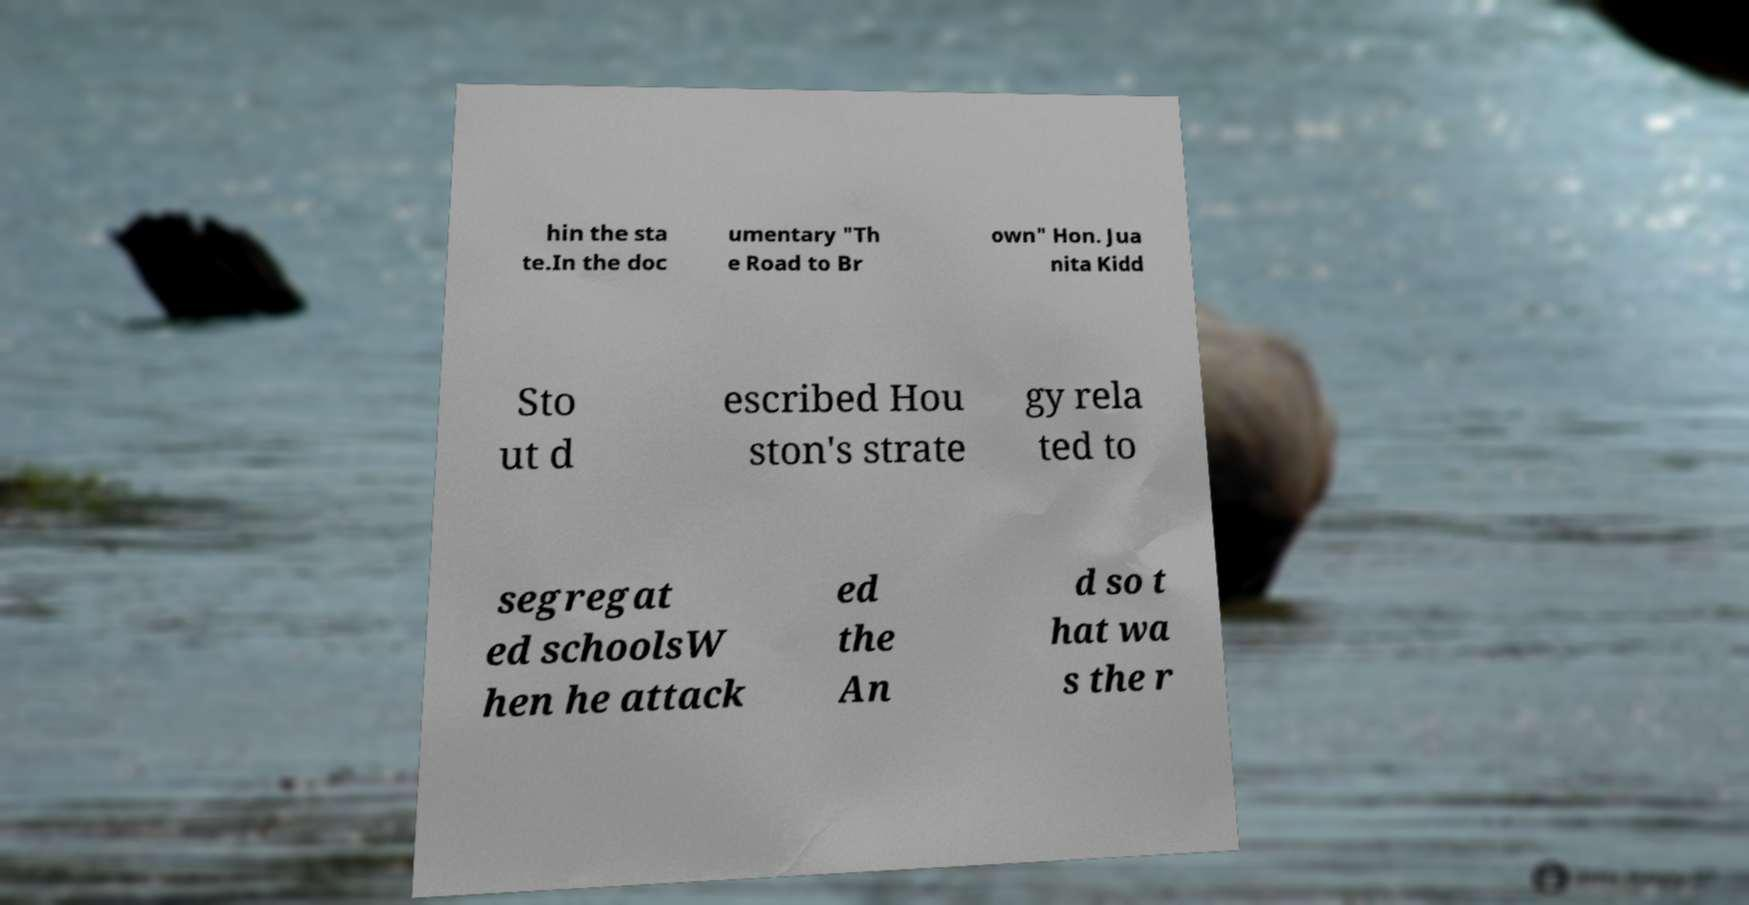There's text embedded in this image that I need extracted. Can you transcribe it verbatim? hin the sta te.In the doc umentary "Th e Road to Br own" Hon. Jua nita Kidd Sto ut d escribed Hou ston's strate gy rela ted to segregat ed schoolsW hen he attack ed the An d so t hat wa s the r 